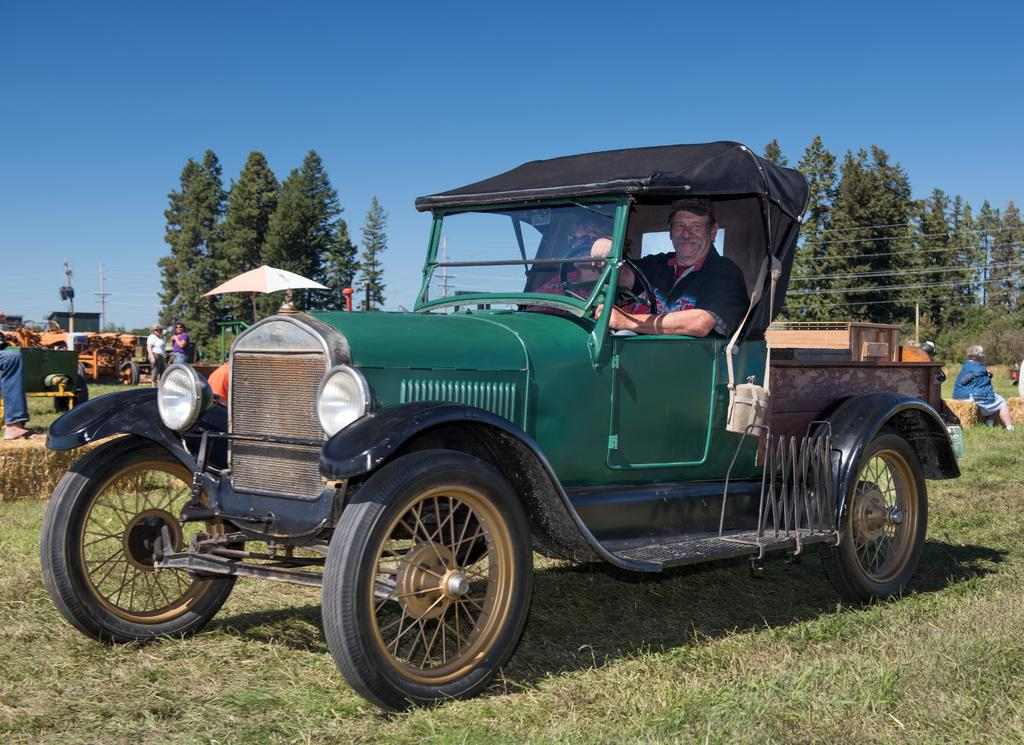What can be seen in the background of the image? There is a clear blue sky, trees, and people walking and sitting in the background. What type of vehicle is present in the image? There is a jeep in the image. Who is inside the jeep? There is a man inside the jeep. What is the ground covered with in the image? The image contains grass. What other object can be seen in the image? There is a pole in the image. What type of company is represented by the flag on the jeep? There is no flag present on the jeep in the image. What does the man inside the jeep have in his mouth? There is no information about the man's mouth or any objects in it in the image. 